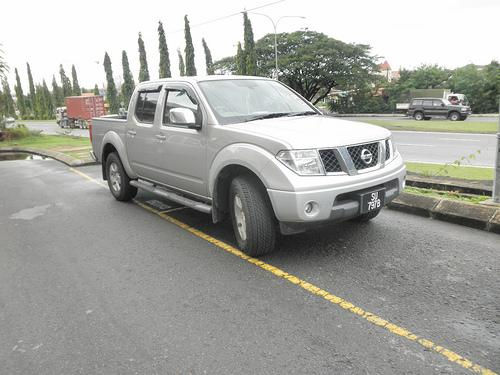What is the luxury division of this motor company? Please explain your reasoning. infinity. This is a nissan, not honda, tata, or toyota, pickup truck. 